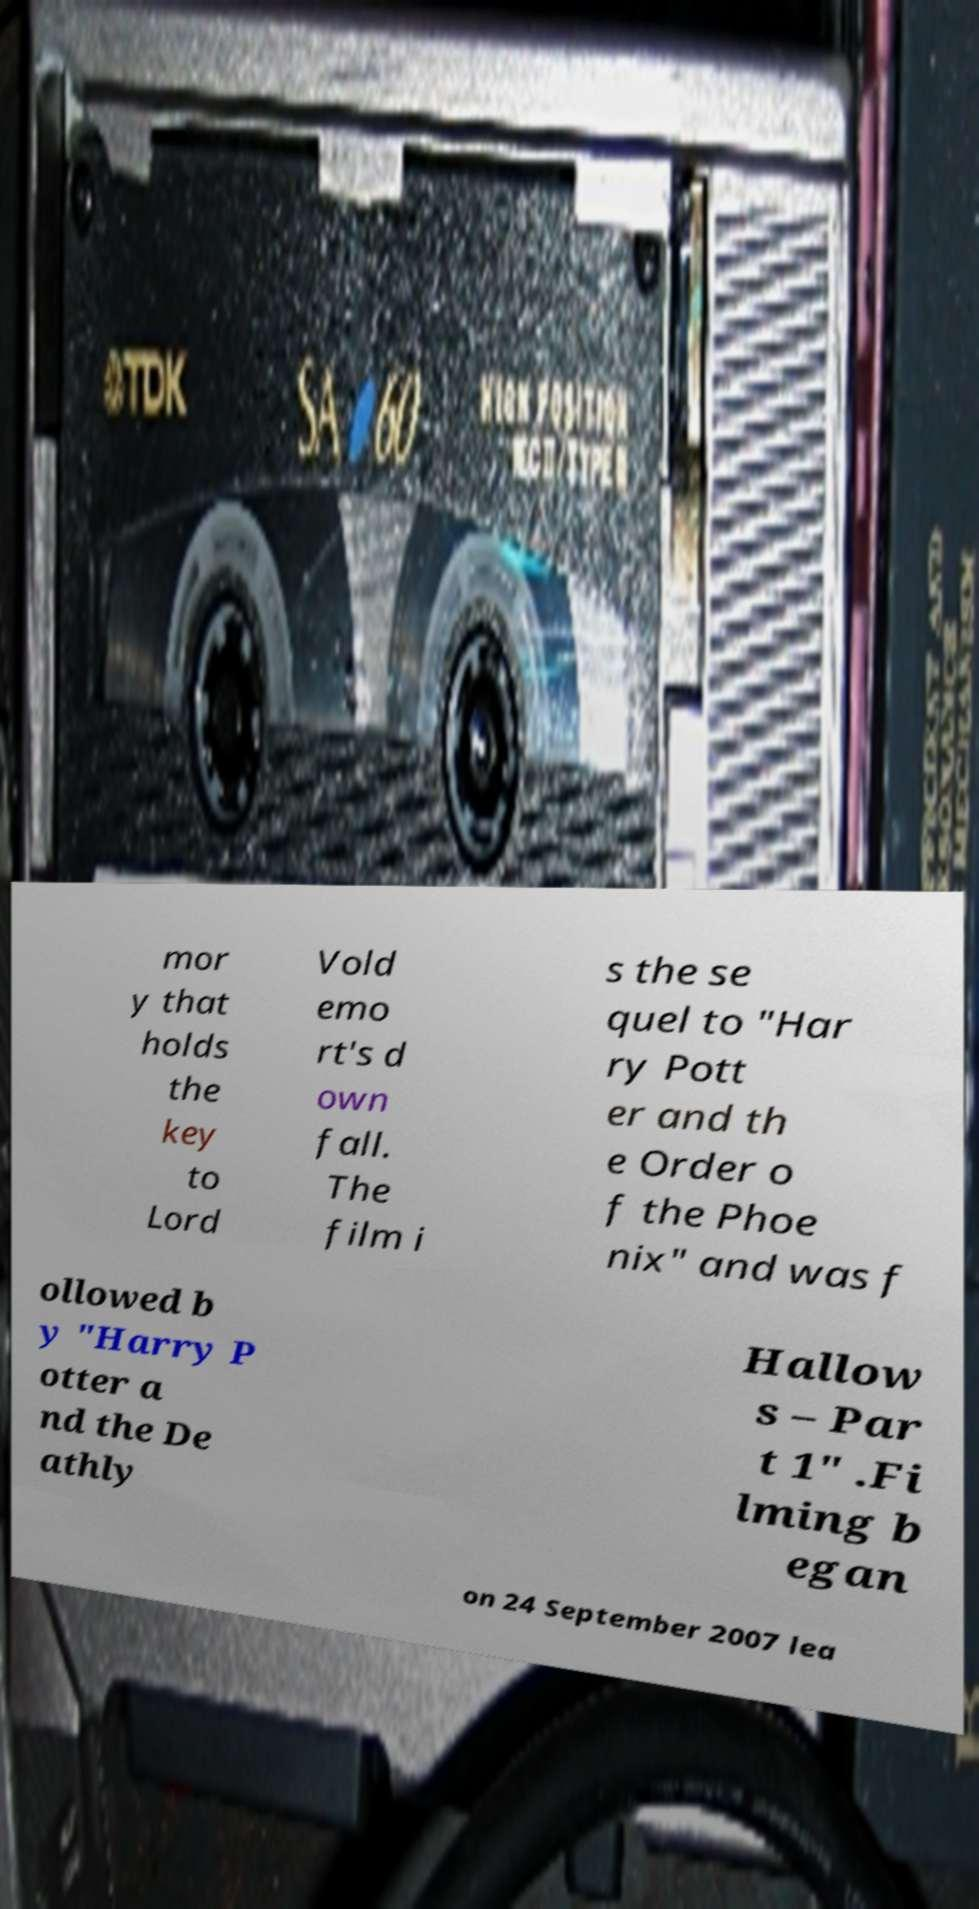Can you read and provide the text displayed in the image?This photo seems to have some interesting text. Can you extract and type it out for me? mor y that holds the key to Lord Vold emo rt's d own fall. The film i s the se quel to "Har ry Pott er and th e Order o f the Phoe nix" and was f ollowed b y "Harry P otter a nd the De athly Hallow s – Par t 1" .Fi lming b egan on 24 September 2007 lea 